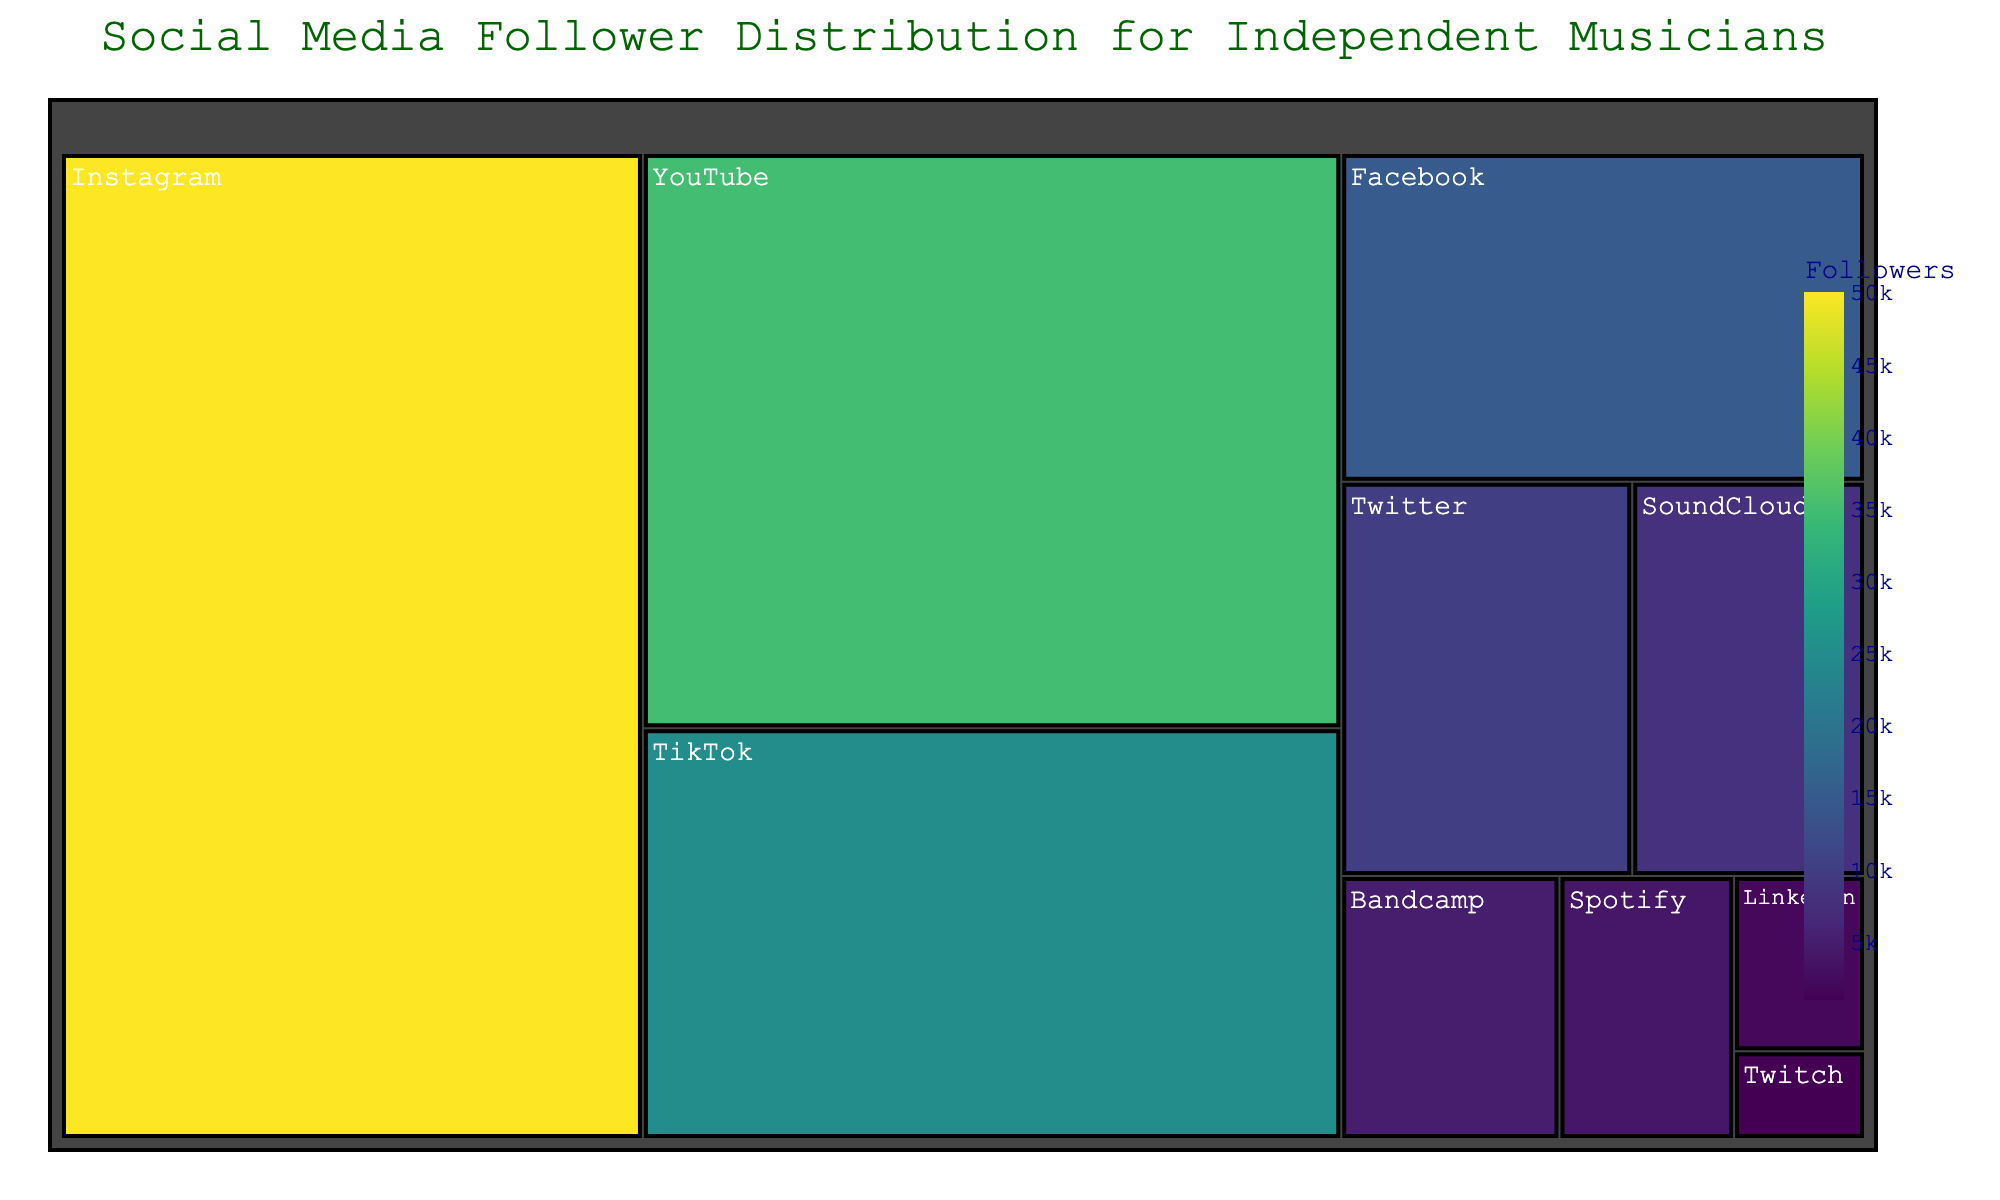How many platforms are shown in the treemap? Count the number of distinct platforms displayed in the figure.
Answer: 10 Which platform has the most followers? Identify the platform with the largest segment size and the highest follower count.
Answer: Instagram How many more followers does Instagram have compared to YouTube? Subtract the followers of YouTube from Instagram's followers (50000 - 35000).
Answer: 15000 What percentage of the total followers are from Instagram? Calculate the total number of followers across all platforms, then divide Instagram's followers by the total and multiply by 100. (50000 / 153000 * 100).
Answer: 32.68% What is the combined number of followers on SoundCloud and Bandcamp? Add followers from SoundCloud and Bandcamp (8000 + 5000).
Answer: 13000 Which platform has the least followers? Identify the platform with the smallest segment size and lowest follower count.
Answer: Twitch Are there more followers on Facebook or Twitter? Compare the follower counts of Facebook and Twitter.
Answer: Facebook How many more followers does TikTok have compared to LinkedIn and Twitch combined? Add the followers of LinkedIn and Twitch, then subtract the sum from TikTok's followers (25000 - (2000 + 1000)).
Answer: 22000 How are the platforms colored in the treemap? Describe the coloring scheme based on the followers' values using a continuous scale (highlighted in shades of Viridis).
Answer: Viridis scale based on follower count Which three platforms have nearly similar follower counts? Identify platforms with close follower counts by checking the sizes in the treemap (SoundCloud, Bandcamp, Spotify).
Answer: SoundCloud, Bandcamp, Spotify 